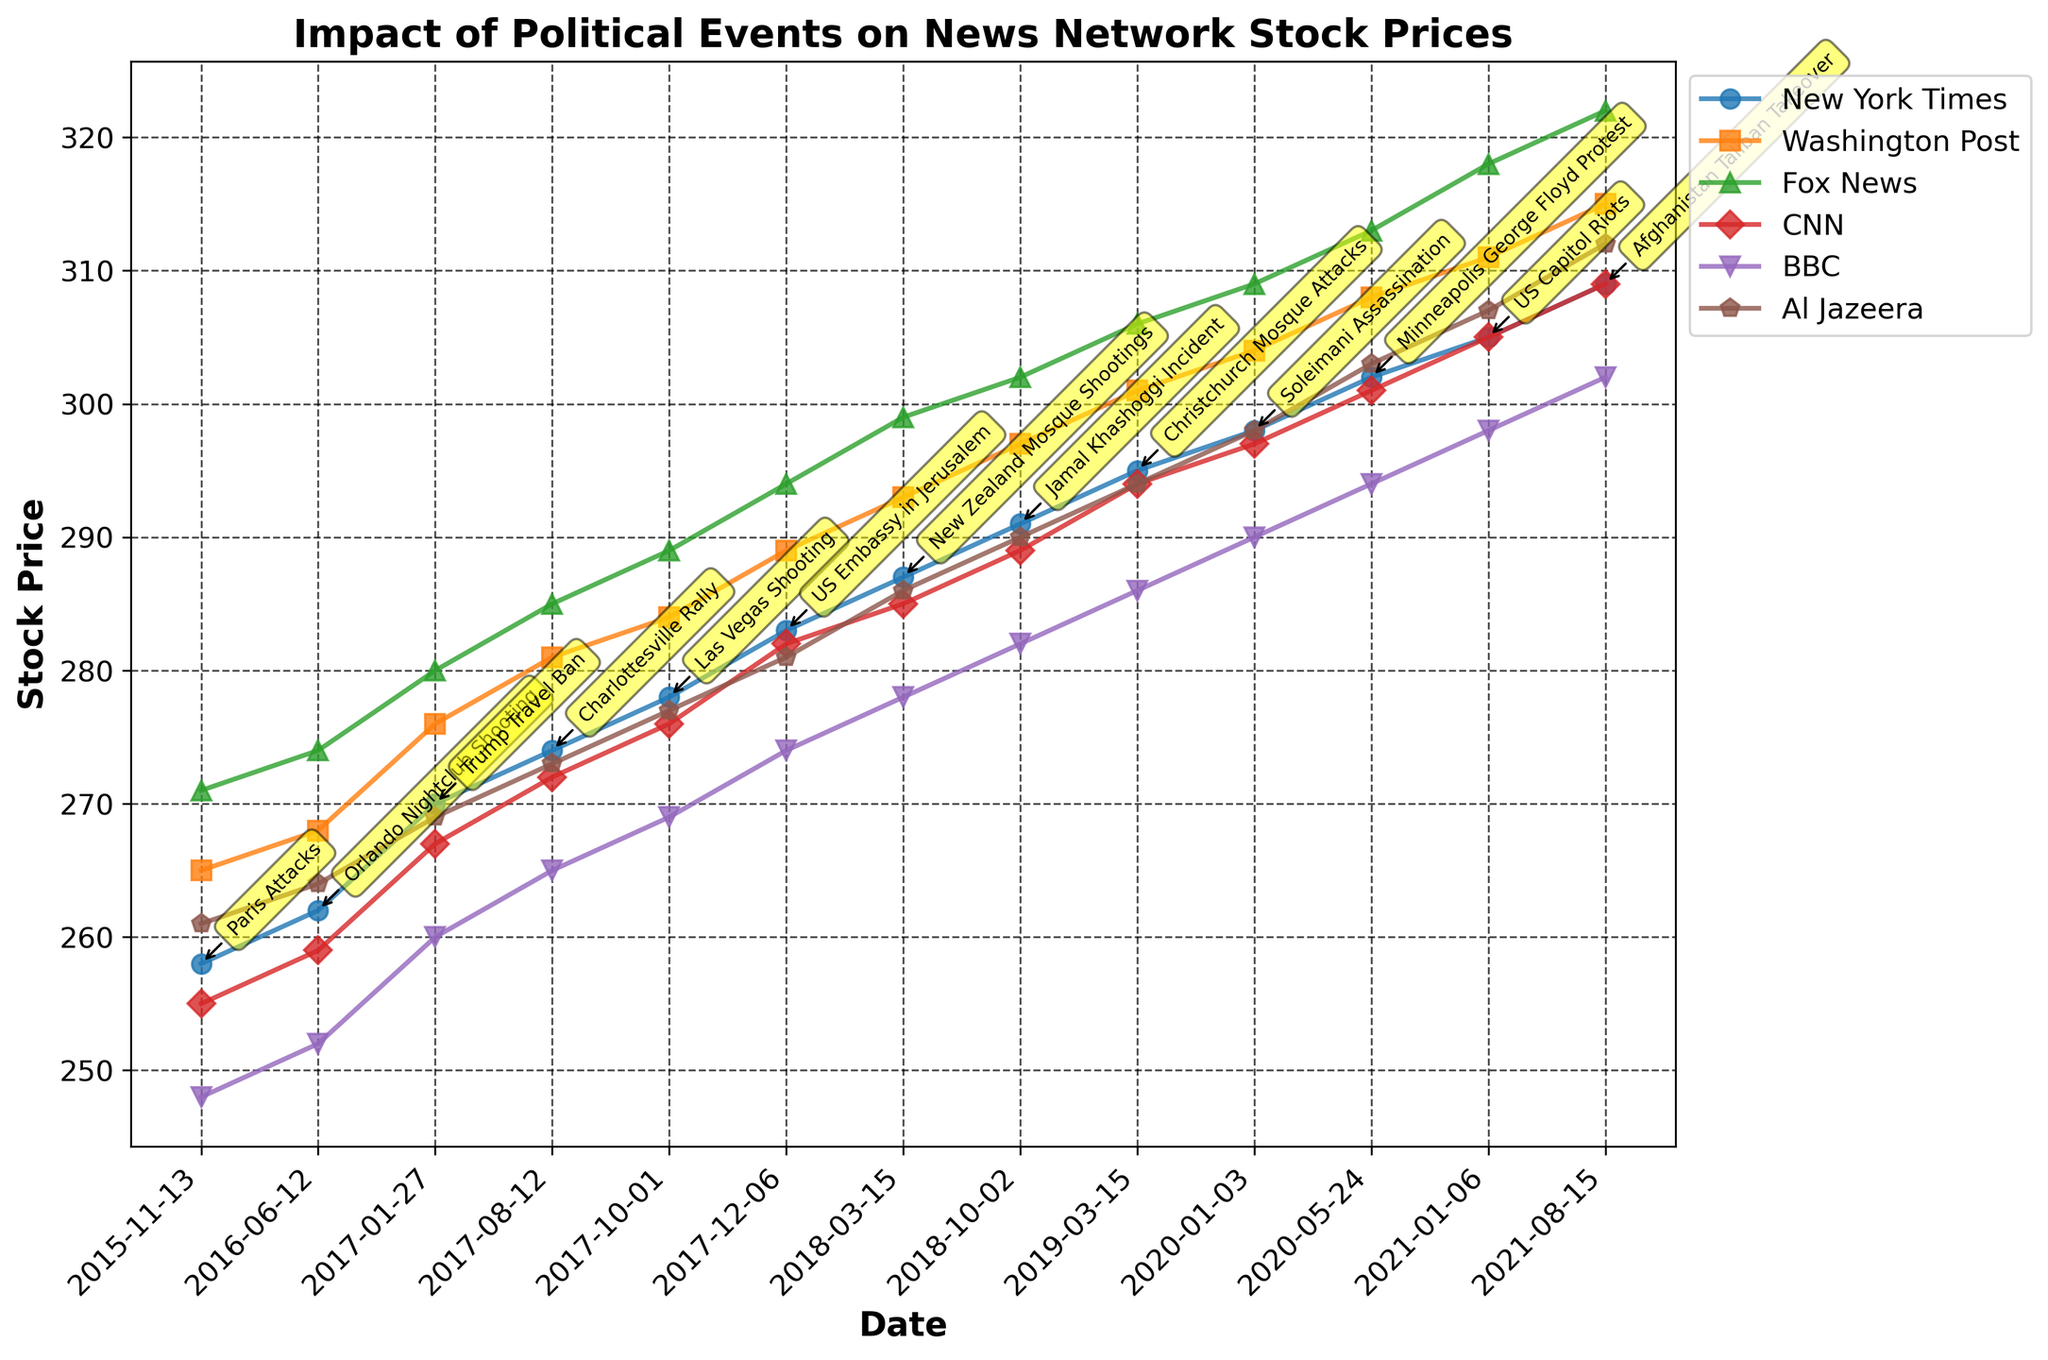What's the title of the plot? The title is found at the top of the chart, indicating the subject of the figure.
Answer: Impact of Political Events on News Network Stock Prices Which news network had the highest stock price before the Orlando Nightclub Shooting event? By looking at the data points before the Orlando Nightclub Shooting, identify the highest stock price among the news networks.
Answer: Fox News During the US Embassy in Jerusalem incident, what were the stock prices for CNN and Al Jazeera? Locate the data point for the US Embassy in Jerusalem event and refer to the corresponding stock prices for CNN and Al Jazeera.
Answer: 282 for CNN, 281 for Al Jazeera What is the trend for New York Times stock prices over the span of the events observed? Follow the trend of the stock prices for New York Times from the first to the last event and observe if they consistently rise, fall, or vary.
Answer: Rising Which event corresponds to the highest stock price rise for Al Jazeera? Track Al Jazeera's stock prices for each event and identify which event shows the highest peak.
Answer: Afghanistan Taliban Takeover Order the stock prices for the US Capitol Riots from highest to lowest across all networks. For the event "US Capitol Riots", list the stock prices for all networks and sort them in descending order.
Answer: Fox News, Washington Post, New York Times, CNN, BBC, Al Jazeera Did any event cause a temporary dip in stock prices for all news networks? Scan the timeline to find any event after which all observed stock prices exhibit a noticeable decline.
Answer: No clear dip, generally increasing trend Calculate the average stock price for BBC across all events. Sum all the recorded stock prices for BBC and divide by the number of events to find the average.
Answer: (248 + 252 + 260 + 265 + 269 + 274 + 278 + 282 + 286 + 290 + 294 + 298 + 302) / 13 = 278.38 Were there any events where the stock price of the Washington Post significantly diverged from the New York Times? Compare the stock prices of Washington Post and New York Times for each event to identify any event with a significant difference.
Answer: No significant divergence found, less than 10 units difference consistently 